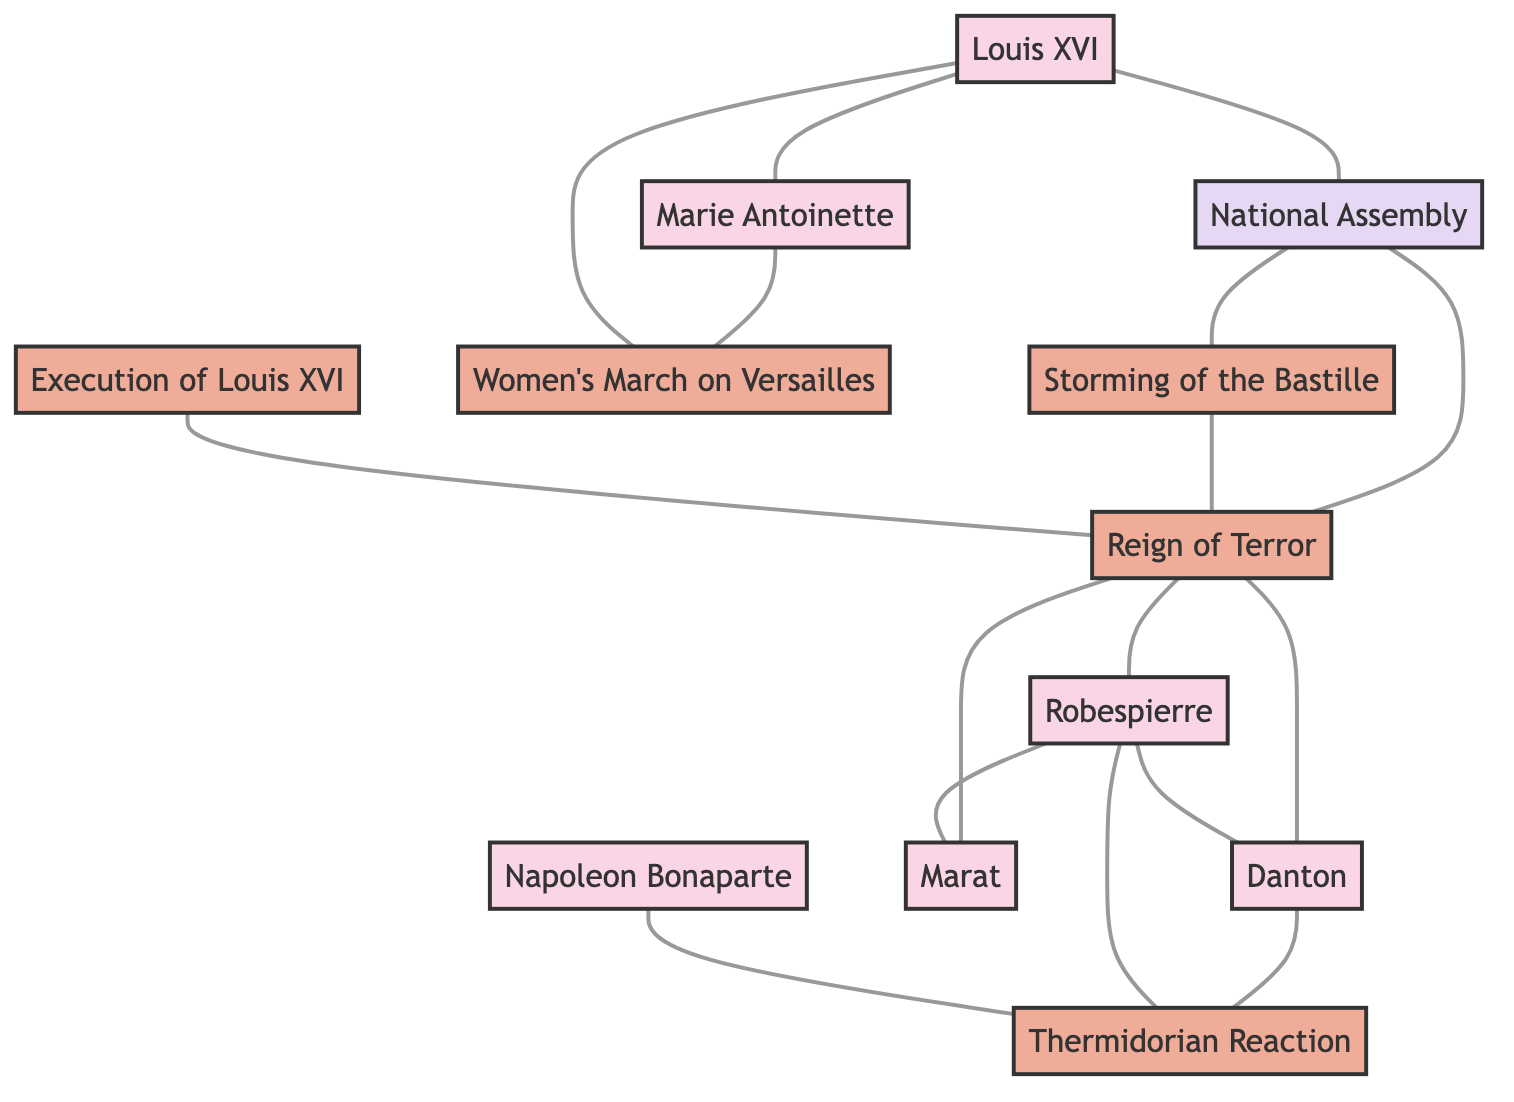What are the total number of nodes in the diagram? By counting the unique entities mentioned in the "nodes" section of the data, we find there are 12 distinct nodes representing historical figures, events, and institutions.
Answer: 12 How many edges are there connecting the nodes? By examining the "edges" section, we count the lines connecting the different nodes. There are 15 edges listed, which indicate the relationships between the nodes.
Answer: 15 Who is connected to the 'National Assembly'? Looking at the edges connected to the 'National Assembly', we see it is connected to 'Louis XVI', 'Storming of the Bastille', and 'Reign of Terror'. Therefore, the direct connections include these three entities.
Answer: Louis XVI, Storming of the Bastille, Reign of Terror Which event is connected to both 'Robespierre' and 'Danton'? The "Reign of Terror" is the event that links both 'Robespierre' and 'Danton', as it is shown in the graph that both figures have edges connecting to this event.
Answer: Reign of Terror What event directly follows the execution of Louis XVI? The graph indicates that the 'Execution of Louis XVI' is directly linked to the 'Reign of Terror', indicating that this event follows immediately after the execution.
Answer: Reign of Terror How are 'Marie Antoinette' and 'Louis XVI' related in the graph? The diagram shows a direct connection (edge) between 'Marie Antoinette' and 'Louis XVI', indicating that they are linked as partners, specifically as husband and wife.
Answer: Spouse Which figure is mentioned alongside the 'Thermidorian Reaction'? The figure 'Napoleon Bonaparte' is connected to the 'Thermidorian Reaction', showing a link between this historical event and Napoleon in the diagram.
Answer: Napoleon Bonaparte How many figures are connected to the 'Reign of Terror'? By observing the edges from 'Reign of Terror', we see it connects to three figures: 'Robespierre', 'Danton', and 'Marat'. Therefore, there are three figures directly connected to this event.
Answer: 3 Which event led to the 'Storming of the Bastille'? The 'National Assembly' is directly linked to the 'Storming of the Bastille', which shows that the actions or decisions made by the assembly contributed to the event itself.
Answer: National Assembly 